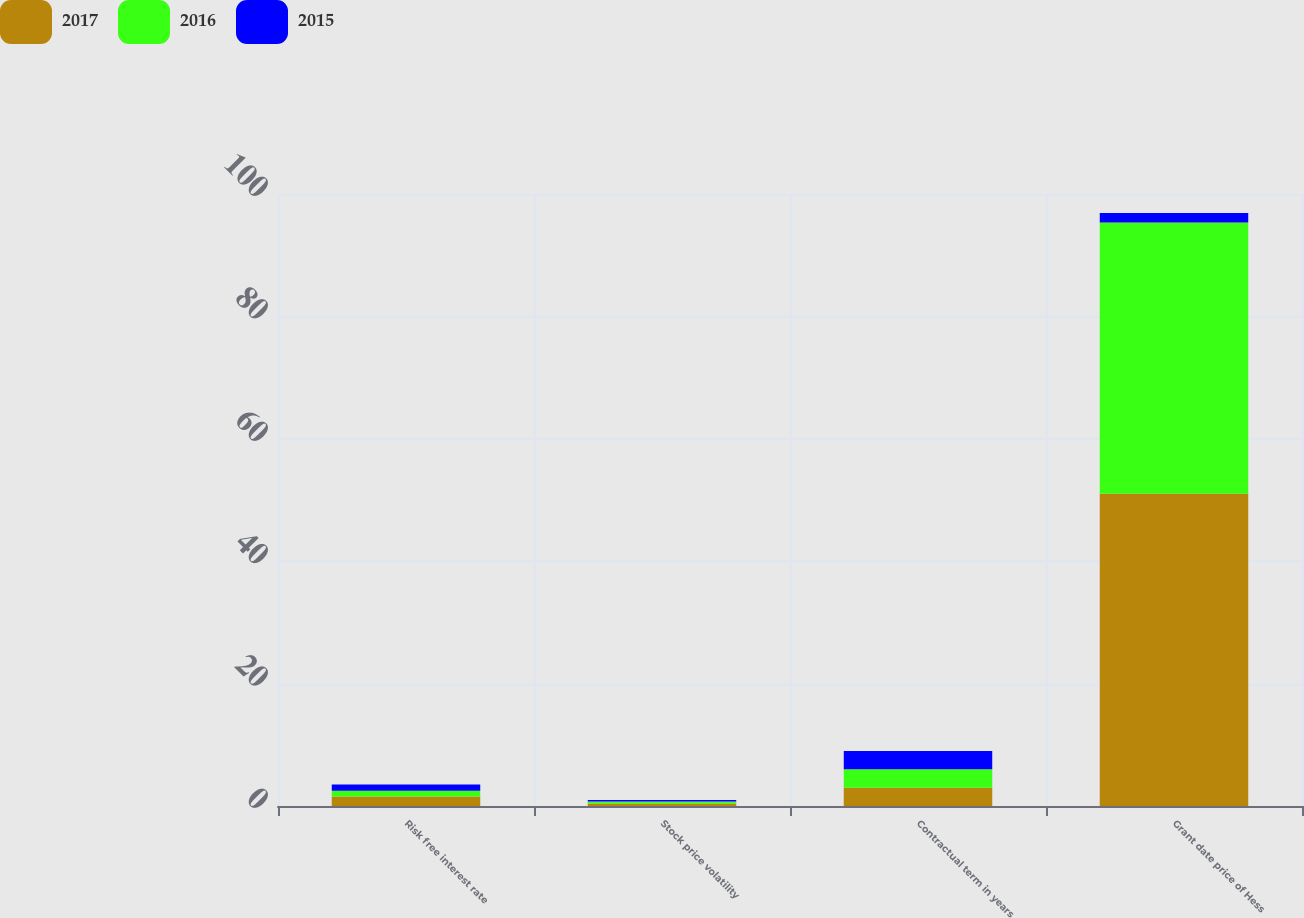Convert chart to OTSL. <chart><loc_0><loc_0><loc_500><loc_500><stacked_bar_chart><ecel><fcel>Risk free interest rate<fcel>Stock price volatility<fcel>Contractual term in years<fcel>Grant date price of Hess<nl><fcel>2017<fcel>1.55<fcel>0.39<fcel>3<fcel>51.03<nl><fcel>2016<fcel>0.96<fcel>0.33<fcel>3<fcel>44.31<nl><fcel>2015<fcel>1.02<fcel>0.27<fcel>3<fcel>1.55<nl></chart> 